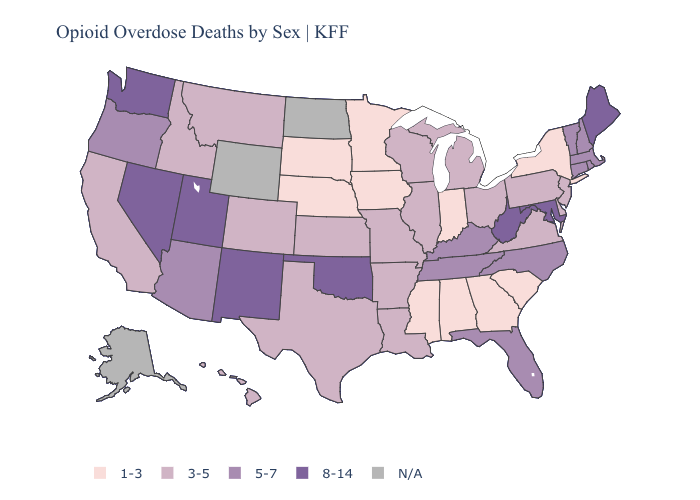Which states have the lowest value in the USA?
Answer briefly. Alabama, Georgia, Indiana, Iowa, Minnesota, Mississippi, Nebraska, New York, South Carolina, South Dakota. Among the states that border Illinois , which have the highest value?
Short answer required. Kentucky. Does Connecticut have the highest value in the USA?
Quick response, please. No. Which states hav the highest value in the West?
Concise answer only. Nevada, New Mexico, Utah, Washington. Does New Mexico have the highest value in the West?
Write a very short answer. Yes. Does Indiana have the highest value in the USA?
Short answer required. No. Does Minnesota have the lowest value in the USA?
Keep it brief. Yes. Name the states that have a value in the range 8-14?
Be succinct. Maine, Maryland, Nevada, New Mexico, Oklahoma, Utah, Washington, West Virginia. Which states hav the highest value in the MidWest?
Quick response, please. Illinois, Kansas, Michigan, Missouri, Ohio, Wisconsin. Name the states that have a value in the range 5-7?
Be succinct. Arizona, Connecticut, Florida, Kentucky, Massachusetts, New Hampshire, North Carolina, Oregon, Rhode Island, Tennessee, Vermont. Name the states that have a value in the range 3-5?
Keep it brief. Arkansas, California, Colorado, Delaware, Hawaii, Idaho, Illinois, Kansas, Louisiana, Michigan, Missouri, Montana, New Jersey, Ohio, Pennsylvania, Texas, Virginia, Wisconsin. Among the states that border Louisiana , which have the lowest value?
Give a very brief answer. Mississippi. Does West Virginia have the lowest value in the USA?
Be succinct. No. Among the states that border Rhode Island , which have the lowest value?
Be succinct. Connecticut, Massachusetts. Name the states that have a value in the range 8-14?
Be succinct. Maine, Maryland, Nevada, New Mexico, Oklahoma, Utah, Washington, West Virginia. 